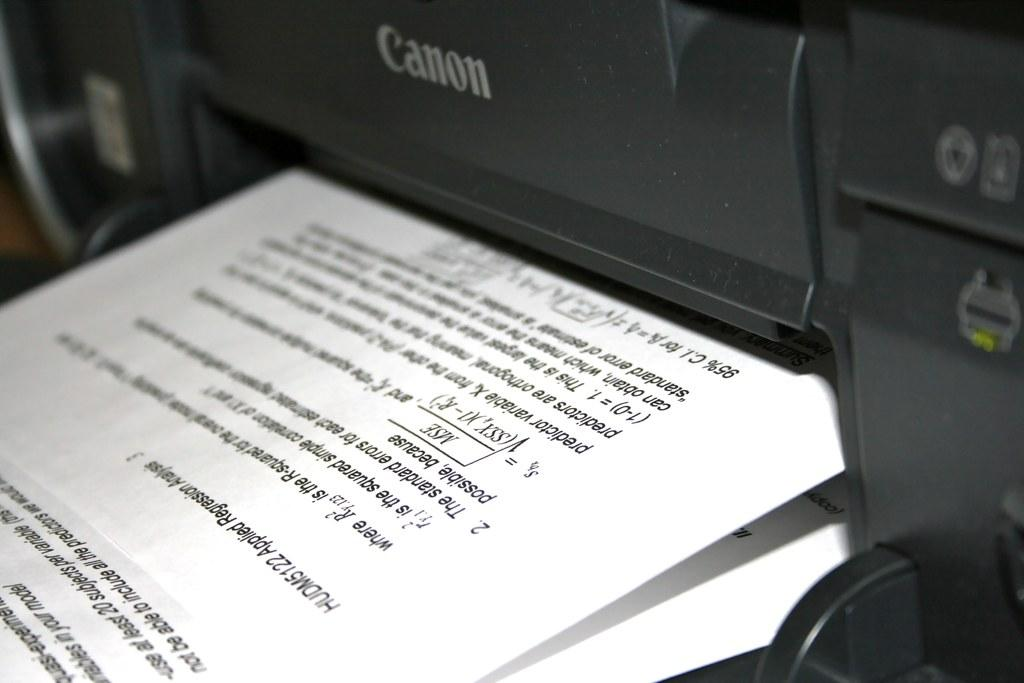What is the main object in the image? There is a printing machine in the image. What is associated with the printing machine in the image? There are papers in the image. What can be found on the papers in the image? The papers contain text. Is there a veil covering the printing machine in the image? No, there is no veil present in the image. Can you tell me the credit score of the person operating the printing machine in the image? There is no information about the credit score of the person operating the printing machine in the image. 